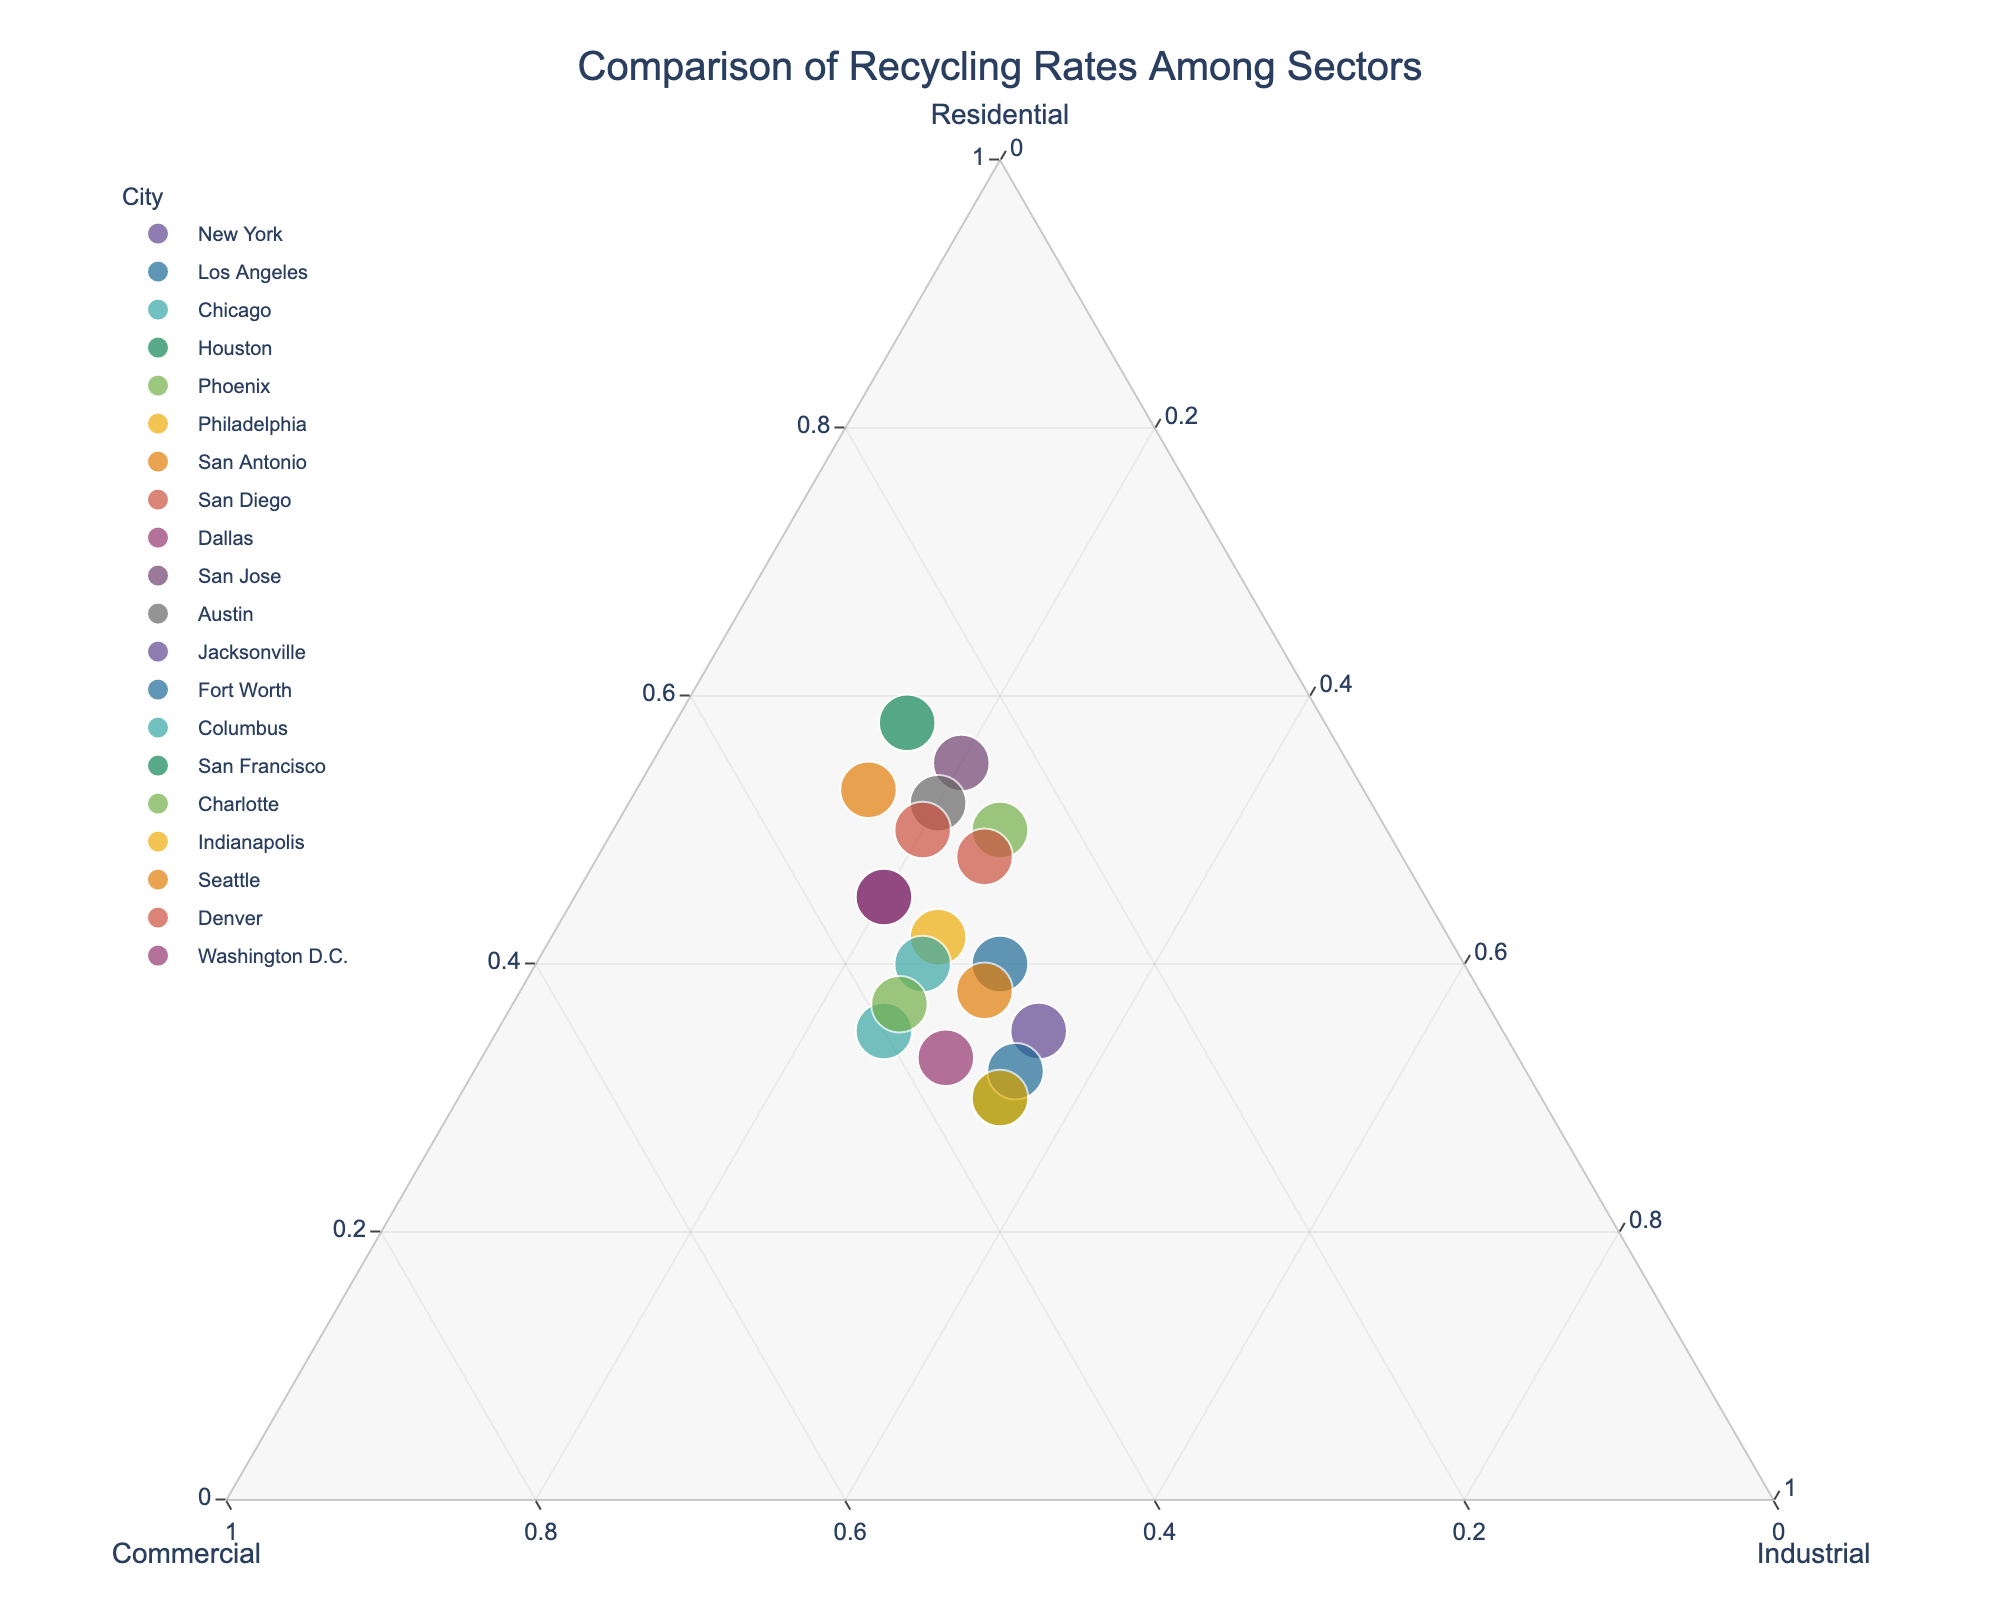Which city has the highest rate of residential recycling? The city closer to the "Residential" vertex in a ternary plot has the highest rate of residential recycling. San Francisco is closest to that vertex.
Answer: San Francisco What is the title of the figure? The title is usually at the top of the plot, indicating what the figure is about.
Answer: Comparison of Recycling Rates Among Sectors Where does Los Angeles fall in terms of industrial recycling rates compared to Phoenix? On a ternary plot, you compare the vertical distance to the "Industrial" vertex. Both Los Angeles and Phoenix are equidistant from the vertex, meaning they have the same industrial recycling rate.
Answer: Equal Which city has the largest share of commercial recycling? The city closer to the "Commercial" vertex in the ternary plot has the largest share of commercial recycling. Charlotte is closest to that vertex.
Answer: Charlotte How many cities have a higher industrial recycling rate than residential? Look for cities closer to the "Industrial" vertex than the "Residential" vertex. They are Houston, Jacksonville, Fort Worth, and Indianapolis, summing up to 4 cities.
Answer: 4 Which city is closest to having an equal distribution across all three sectors? The city closer to the center of the ternary plot is more balanced across all sectors. Houston is closest to this point.
Answer: Houston What is the combined residential and industrial recycling rate for Seattle? In a ternary plot, identify the city's coordinates for Residential and Industrial. For Seattle, Residential is 53% and Industrial is 15%. The combined rate is 53% + 15%.
Answer: 68% Is there any city with an industrial recycling rate less than 15%? Check the proximity to the "Industrial" vertex. Both San Francisco and Seattle have an industrial recycling rate exactly at 15%, but none below it.
Answer: No Which cities have the same residential recycling rate? Look for cities aligned horizontally at the same Residential value. Both New York and Washington D.C. share the same residential recycling rate of 45%.
Answer: New York, Washington D.C What trend can you observe about industrial recycling rates in smaller cities? Identify cities with smaller industrial recycling rates and observe their locations. Smaller cities tend to cluster away from the Industrial vertex, indicating lower rates.
Answer: Smaller cities generally have lower industrial rates 